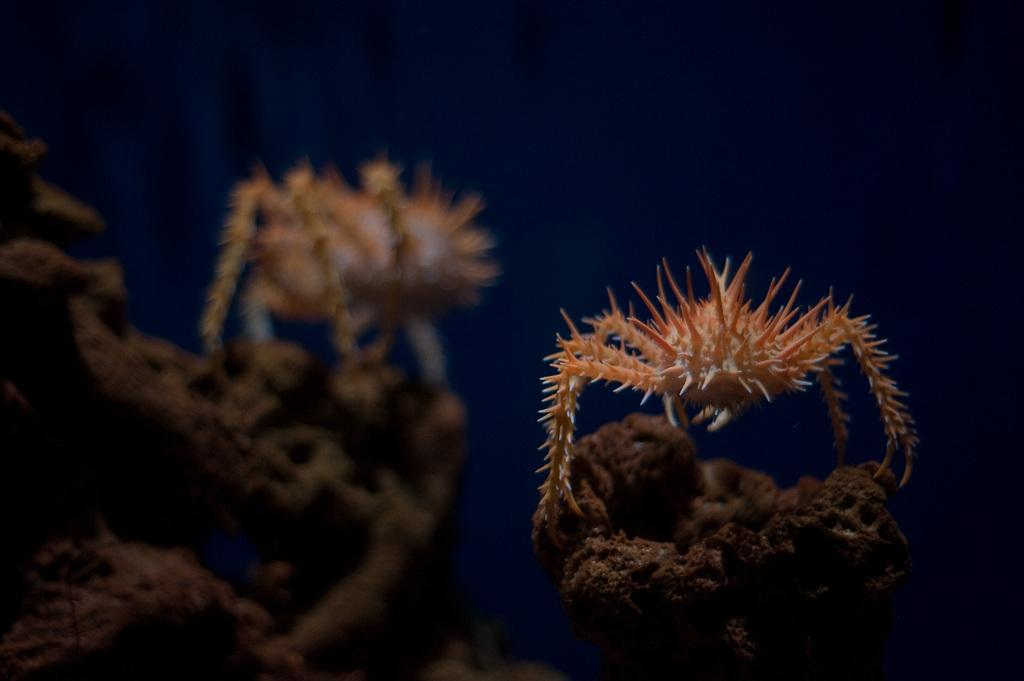How many insects are present in the image? There are two insects in the image. What are the insects doing in the image? The insects are on a sand structure. What type of wave can be seen crashing on the shore in the image? There is no wave or shore present in the image; it features two insects on a sand structure. What thought might the insects be having while on the sand structure in the image? It is impossible to determine the thoughts of the insects in the image, as insects do not have the ability to think or have thoughts like humans. 